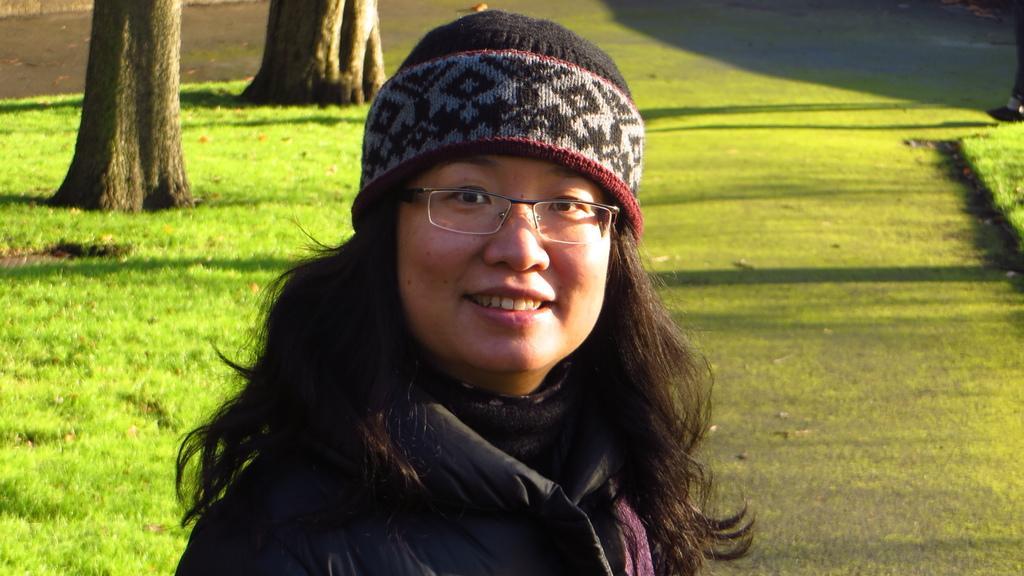Can you describe this image briefly? In this image we can see one woman with spectacles standing in a park. There are two big trees, some green grass and one object on the surface. 